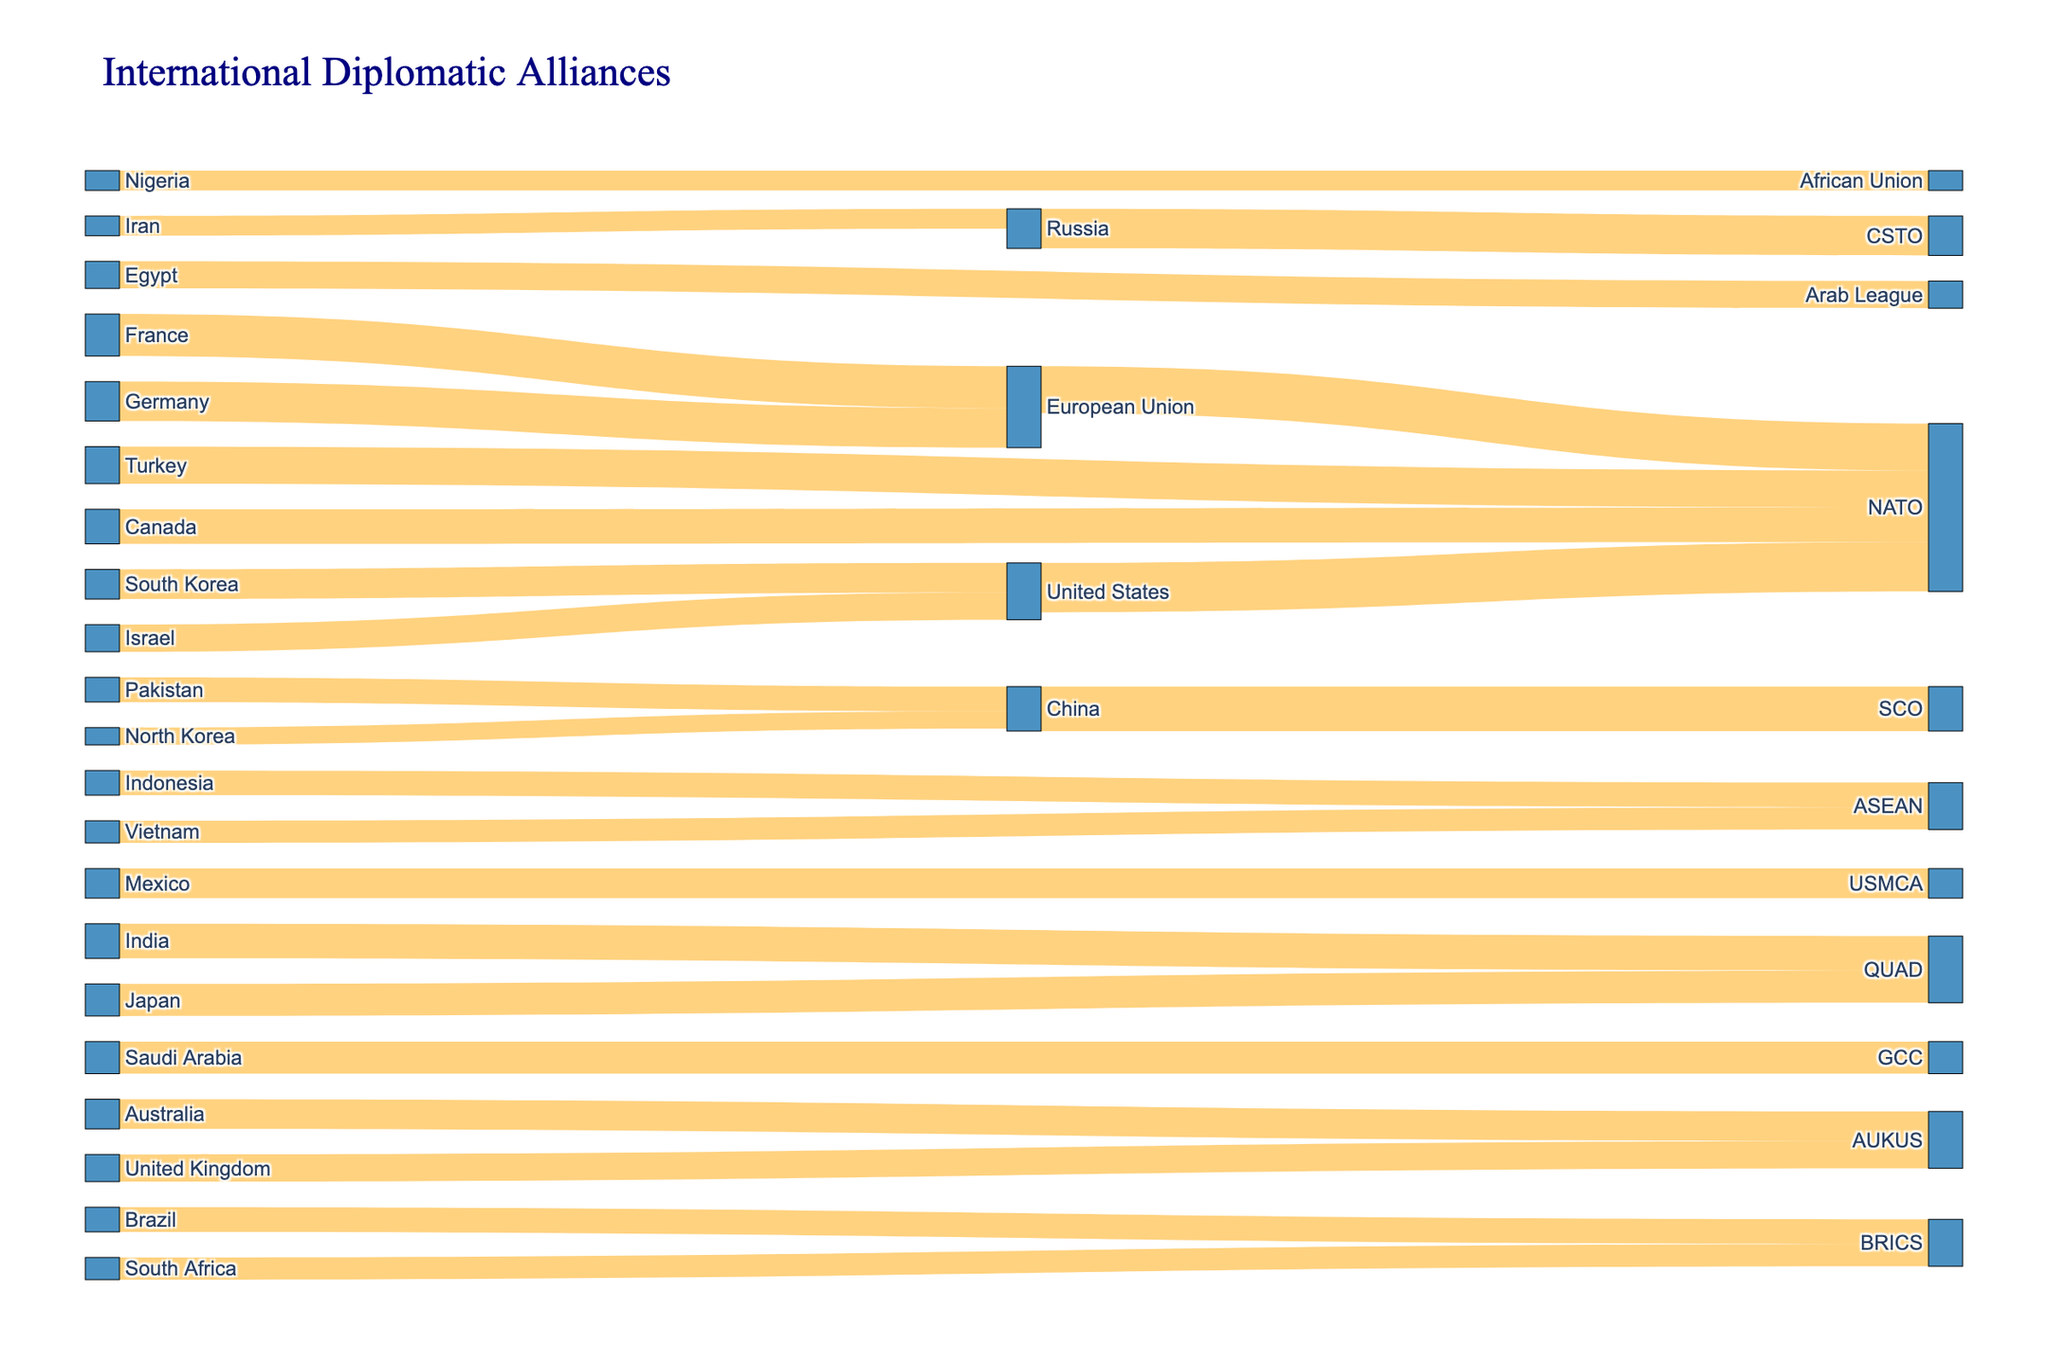What is the title of the Sankey Diagram? The title of the diagram is located at the top of the figure and provides a description of what the diagram represents. By reading the text at the top, we can determine the title.
Answer: International Diplomatic Alliances Which nation contributes the most to the NATO alliance? To find out which nation contributes the most to NATO, we need to look at the nodes connected to NATO and observe the values of their links. The node with the highest value link to NATO is the answer.
Answer: United States How many countries are part of the BRICS alliance according to the diagram? Locate the BRICS alliance node and count the number of incoming links, each representing a different country. These links indicate the number of countries in the BRICS alliance.
Answer: Two What is the combined strength of the QUAD alliance? To determine the combined strength of the QUAD alliance, sum up the values of the incoming links to the QUAD node. The values from India (70) and Japan (65) need to be added together.
Answer: 135 Which alliance has fewer members, ASEAN or AUKUS? To compare the number of members, count the incoming links to each respective node (ASEAN and AUKUS). ASEAN has two incoming links (Vietnam and Indonesia), while AUKUS has two as well (Australia and United Kingdom). Both alliances have the same number of members.
Answer: They have the same number of members What is the value difference between China's alliances with SCO and BRICS? Identify the values of the links between China and SCO (90) and China and BRICS (40). Subtract the value of the link to BRICS from the value of the link to SCO to find the difference.
Answer: 50 Which country has alliances with the highest number of unique groups? Count the number of different target nodes that each country's links connect to. The country with the most unique target nodes is the one that has alliances with the highest number of unique groups.
Answer: United States How much is the total value of countries allied with NATO? Sum the values of all the links going into the NATO node. These include contributions from the United States (100), European Union (95), Turkey (75), and Canada (70). Total is 100 + 95 + 75 + 70.
Answer: 340 Among NATO and ASEAN, which has lesser value from its contributing countries? Calculate the total values by summing up the values of the incoming links to NATO and ASEAN nodes. ASEAN has values from Vietnam (45) and Indonesia (50), totaling 95. NATO's total from earlier calculation is 340. Compare these totals.
Answer: ASEAN 